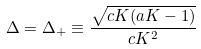Convert formula to latex. <formula><loc_0><loc_0><loc_500><loc_500>\Delta = \Delta _ { + } \equiv \frac { \sqrt { c K ( a K - 1 ) } } { c K ^ { 2 } }</formula> 